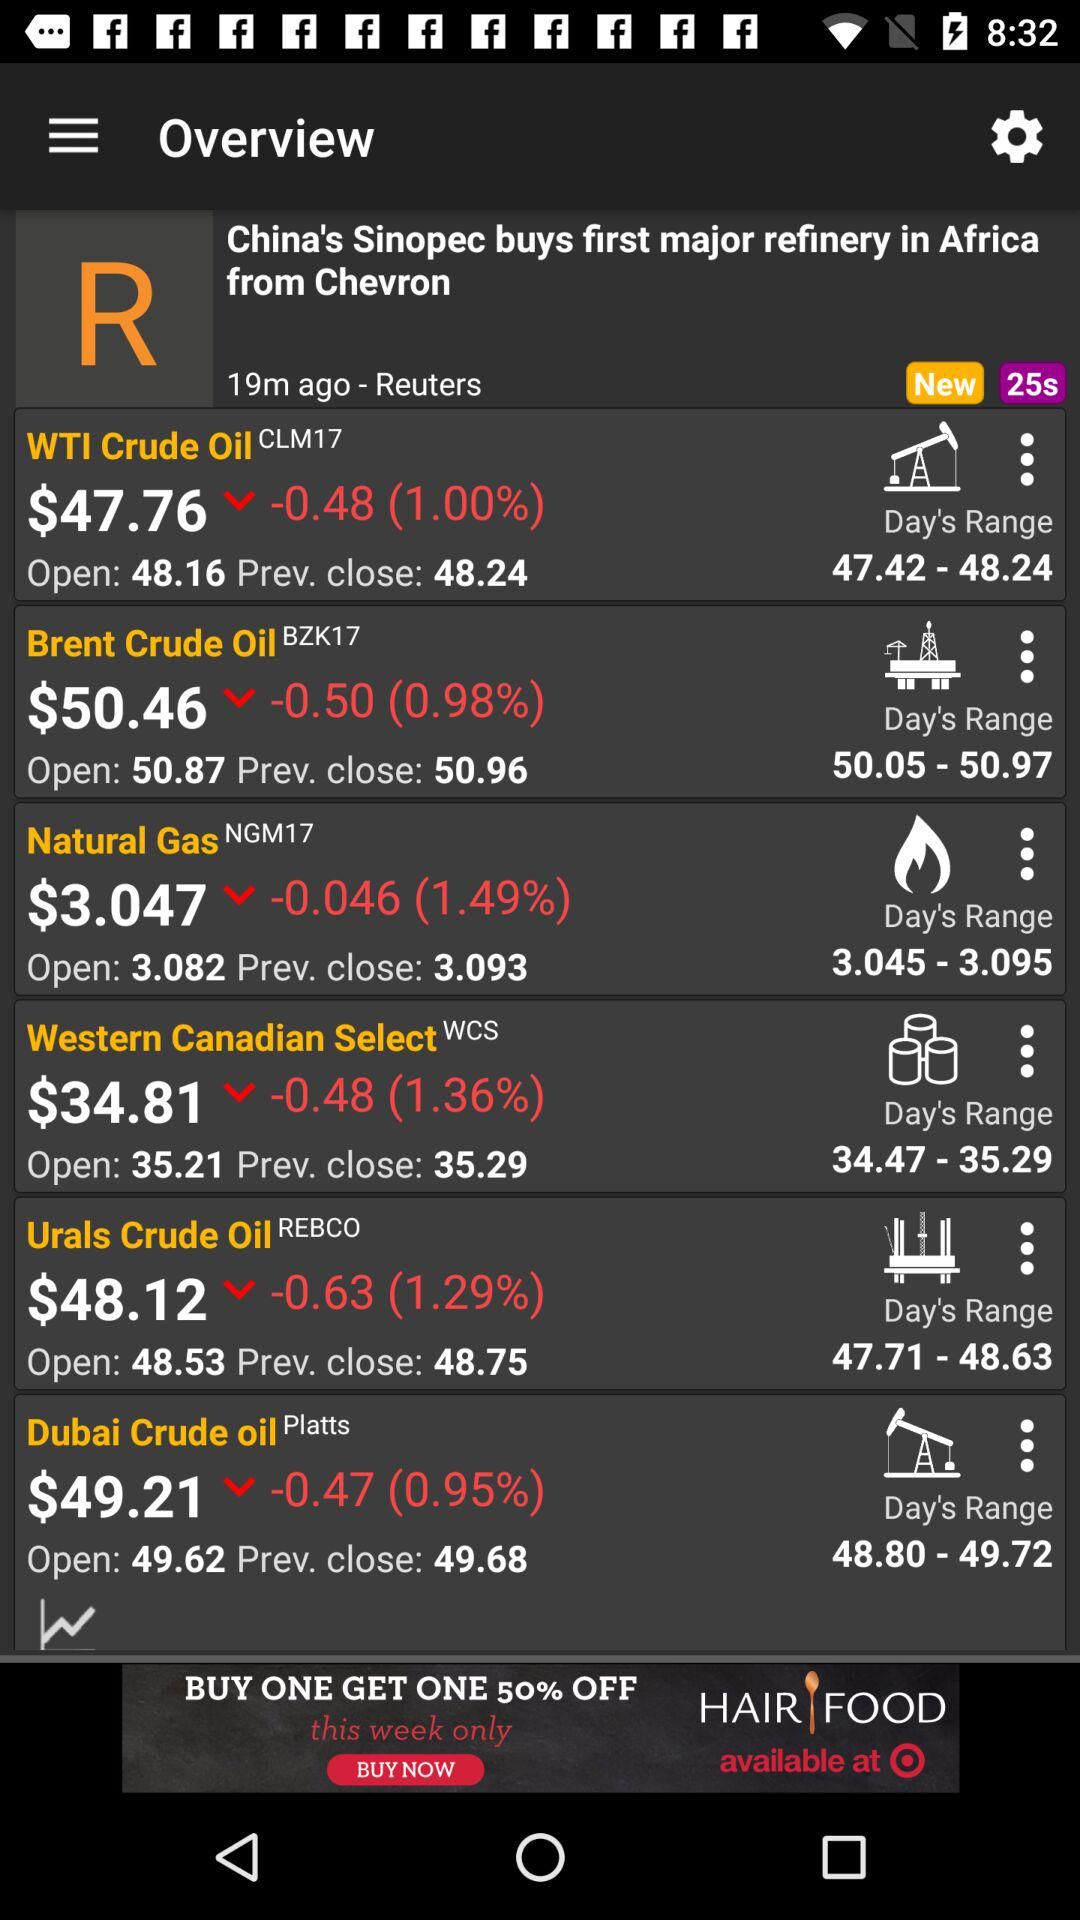What is the decrease in the percentage stock price of "Dubai Crude Oil"? The decrease in the value is 0.95%. 